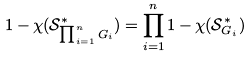Convert formula to latex. <formula><loc_0><loc_0><loc_500><loc_500>1 - \chi ( \mathcal { S } _ { \prod _ { i = 1 } ^ { n } G _ { i } } ^ { * } ) = \prod _ { i = 1 } ^ { n } 1 - \chi ( \mathcal { S } _ { G _ { i } } ^ { * } )</formula> 